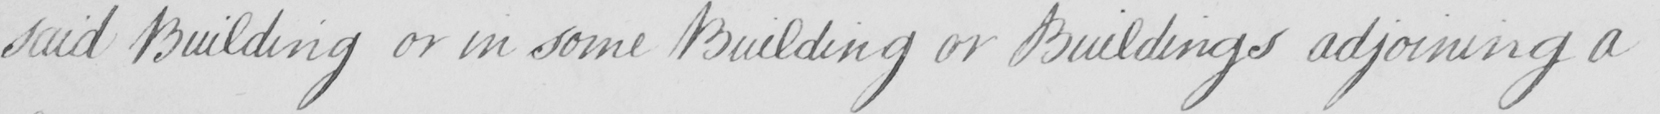Please provide the text content of this handwritten line. said building or in some Building or Buildings adjoining a 